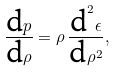Convert formula to latex. <formula><loc_0><loc_0><loc_500><loc_500>\frac { \text  dp}{\text  d\rho}=\rho\,\frac{\text  d^{2} \epsilon } { \text  d\rho^{2} } ,</formula> 